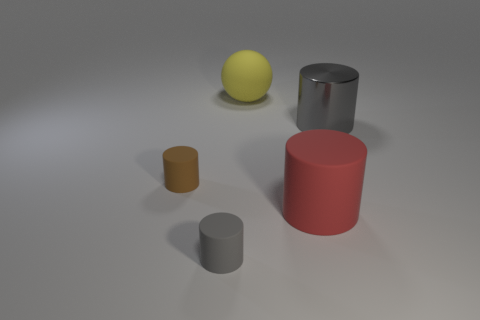Subtract all large red matte cylinders. How many cylinders are left? 3 Subtract all brown cylinders. How many cylinders are left? 3 Subtract 2 cylinders. How many cylinders are left? 2 Add 5 yellow matte objects. How many yellow matte objects are left? 6 Add 4 large balls. How many large balls exist? 5 Add 1 red rubber blocks. How many objects exist? 6 Subtract 0 green blocks. How many objects are left? 5 Subtract all cylinders. How many objects are left? 1 Subtract all red cylinders. Subtract all yellow balls. How many cylinders are left? 3 Subtract all purple cylinders. How many purple balls are left? 0 